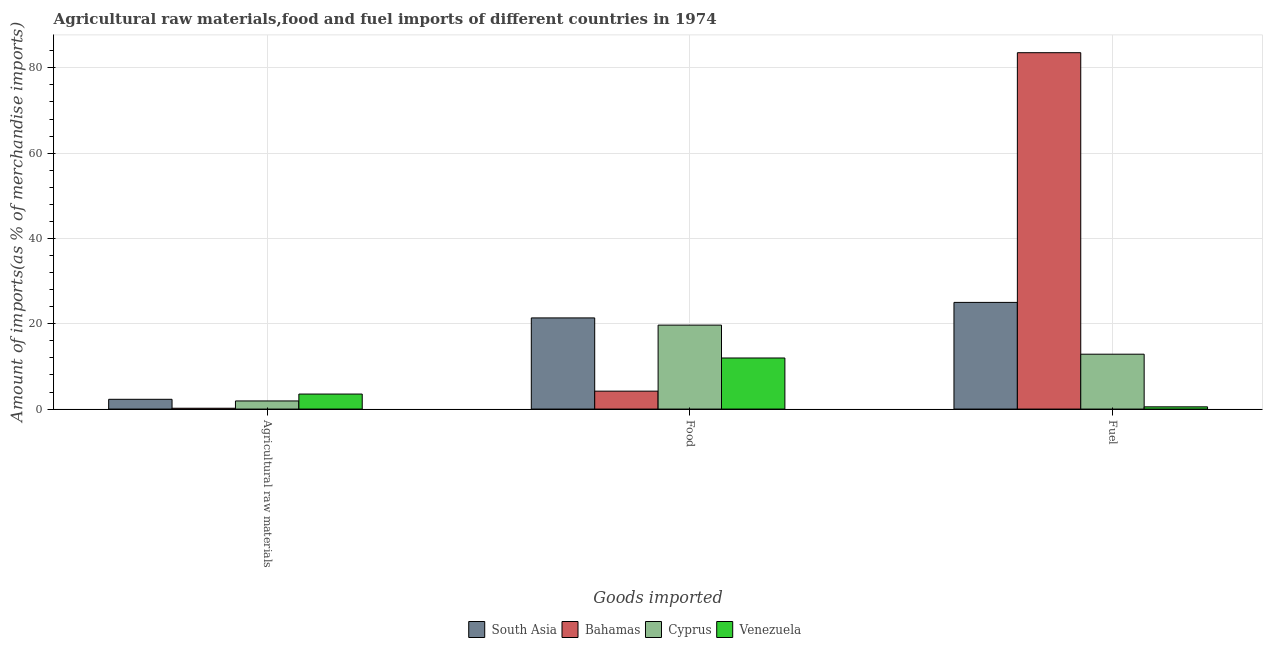How many groups of bars are there?
Your answer should be compact. 3. Are the number of bars per tick equal to the number of legend labels?
Give a very brief answer. Yes. Are the number of bars on each tick of the X-axis equal?
Make the answer very short. Yes. How many bars are there on the 3rd tick from the left?
Offer a terse response. 4. What is the label of the 1st group of bars from the left?
Provide a short and direct response. Agricultural raw materials. What is the percentage of food imports in Venezuela?
Offer a terse response. 11.98. Across all countries, what is the maximum percentage of fuel imports?
Your answer should be compact. 83.55. Across all countries, what is the minimum percentage of fuel imports?
Offer a terse response. 0.52. In which country was the percentage of raw materials imports maximum?
Provide a succinct answer. Venezuela. In which country was the percentage of fuel imports minimum?
Provide a short and direct response. Venezuela. What is the total percentage of food imports in the graph?
Make the answer very short. 57.24. What is the difference between the percentage of food imports in South Asia and that in Cyprus?
Provide a short and direct response. 1.69. What is the difference between the percentage of fuel imports in Cyprus and the percentage of food imports in South Asia?
Your response must be concise. -8.5. What is the average percentage of fuel imports per country?
Your answer should be very brief. 30.49. What is the difference between the percentage of fuel imports and percentage of food imports in Cyprus?
Your answer should be very brief. -6.82. In how many countries, is the percentage of fuel imports greater than 72 %?
Keep it short and to the point. 1. What is the ratio of the percentage of raw materials imports in Cyprus to that in Bahamas?
Provide a succinct answer. 9.67. Is the percentage of food imports in Cyprus less than that in Bahamas?
Keep it short and to the point. No. What is the difference between the highest and the second highest percentage of food imports?
Your answer should be compact. 1.69. What is the difference between the highest and the lowest percentage of raw materials imports?
Your answer should be very brief. 3.33. In how many countries, is the percentage of raw materials imports greater than the average percentage of raw materials imports taken over all countries?
Keep it short and to the point. 2. Is the sum of the percentage of raw materials imports in Bahamas and South Asia greater than the maximum percentage of food imports across all countries?
Keep it short and to the point. No. What does the 3rd bar from the left in Food represents?
Offer a very short reply. Cyprus. What does the 2nd bar from the right in Agricultural raw materials represents?
Your answer should be compact. Cyprus. Are all the bars in the graph horizontal?
Your response must be concise. No. How many countries are there in the graph?
Keep it short and to the point. 4. How are the legend labels stacked?
Ensure brevity in your answer.  Horizontal. What is the title of the graph?
Give a very brief answer. Agricultural raw materials,food and fuel imports of different countries in 1974. Does "Monaco" appear as one of the legend labels in the graph?
Keep it short and to the point. No. What is the label or title of the X-axis?
Your answer should be compact. Goods imported. What is the label or title of the Y-axis?
Give a very brief answer. Amount of imports(as % of merchandise imports). What is the Amount of imports(as % of merchandise imports) in South Asia in Agricultural raw materials?
Provide a short and direct response. 2.29. What is the Amount of imports(as % of merchandise imports) of Bahamas in Agricultural raw materials?
Your answer should be compact. 0.2. What is the Amount of imports(as % of merchandise imports) in Cyprus in Agricultural raw materials?
Offer a terse response. 1.91. What is the Amount of imports(as % of merchandise imports) in Venezuela in Agricultural raw materials?
Your answer should be compact. 3.52. What is the Amount of imports(as % of merchandise imports) in South Asia in Food?
Provide a short and direct response. 21.37. What is the Amount of imports(as % of merchandise imports) in Bahamas in Food?
Ensure brevity in your answer.  4.2. What is the Amount of imports(as % of merchandise imports) of Cyprus in Food?
Provide a succinct answer. 19.68. What is the Amount of imports(as % of merchandise imports) in Venezuela in Food?
Offer a terse response. 11.98. What is the Amount of imports(as % of merchandise imports) in South Asia in Fuel?
Give a very brief answer. 25.01. What is the Amount of imports(as % of merchandise imports) of Bahamas in Fuel?
Provide a short and direct response. 83.55. What is the Amount of imports(as % of merchandise imports) in Cyprus in Fuel?
Offer a very short reply. 12.87. What is the Amount of imports(as % of merchandise imports) of Venezuela in Fuel?
Provide a succinct answer. 0.52. Across all Goods imported, what is the maximum Amount of imports(as % of merchandise imports) of South Asia?
Offer a terse response. 25.01. Across all Goods imported, what is the maximum Amount of imports(as % of merchandise imports) of Bahamas?
Provide a succinct answer. 83.55. Across all Goods imported, what is the maximum Amount of imports(as % of merchandise imports) in Cyprus?
Keep it short and to the point. 19.68. Across all Goods imported, what is the maximum Amount of imports(as % of merchandise imports) of Venezuela?
Ensure brevity in your answer.  11.98. Across all Goods imported, what is the minimum Amount of imports(as % of merchandise imports) of South Asia?
Offer a terse response. 2.29. Across all Goods imported, what is the minimum Amount of imports(as % of merchandise imports) of Bahamas?
Keep it short and to the point. 0.2. Across all Goods imported, what is the minimum Amount of imports(as % of merchandise imports) of Cyprus?
Your answer should be very brief. 1.91. Across all Goods imported, what is the minimum Amount of imports(as % of merchandise imports) in Venezuela?
Your answer should be very brief. 0.52. What is the total Amount of imports(as % of merchandise imports) in South Asia in the graph?
Keep it short and to the point. 48.67. What is the total Amount of imports(as % of merchandise imports) in Bahamas in the graph?
Ensure brevity in your answer.  87.95. What is the total Amount of imports(as % of merchandise imports) of Cyprus in the graph?
Your response must be concise. 34.46. What is the total Amount of imports(as % of merchandise imports) of Venezuela in the graph?
Offer a very short reply. 16.02. What is the difference between the Amount of imports(as % of merchandise imports) in South Asia in Agricultural raw materials and that in Food?
Make the answer very short. -19.08. What is the difference between the Amount of imports(as % of merchandise imports) of Bahamas in Agricultural raw materials and that in Food?
Ensure brevity in your answer.  -4.01. What is the difference between the Amount of imports(as % of merchandise imports) in Cyprus in Agricultural raw materials and that in Food?
Your answer should be compact. -17.78. What is the difference between the Amount of imports(as % of merchandise imports) of Venezuela in Agricultural raw materials and that in Food?
Your answer should be compact. -8.45. What is the difference between the Amount of imports(as % of merchandise imports) in South Asia in Agricultural raw materials and that in Fuel?
Make the answer very short. -22.72. What is the difference between the Amount of imports(as % of merchandise imports) of Bahamas in Agricultural raw materials and that in Fuel?
Ensure brevity in your answer.  -83.36. What is the difference between the Amount of imports(as % of merchandise imports) of Cyprus in Agricultural raw materials and that in Fuel?
Make the answer very short. -10.96. What is the difference between the Amount of imports(as % of merchandise imports) of Venezuela in Agricultural raw materials and that in Fuel?
Your answer should be very brief. 3. What is the difference between the Amount of imports(as % of merchandise imports) of South Asia in Food and that in Fuel?
Offer a very short reply. -3.64. What is the difference between the Amount of imports(as % of merchandise imports) in Bahamas in Food and that in Fuel?
Provide a succinct answer. -79.35. What is the difference between the Amount of imports(as % of merchandise imports) in Cyprus in Food and that in Fuel?
Offer a terse response. 6.82. What is the difference between the Amount of imports(as % of merchandise imports) of Venezuela in Food and that in Fuel?
Your response must be concise. 11.45. What is the difference between the Amount of imports(as % of merchandise imports) in South Asia in Agricultural raw materials and the Amount of imports(as % of merchandise imports) in Bahamas in Food?
Your answer should be compact. -1.91. What is the difference between the Amount of imports(as % of merchandise imports) in South Asia in Agricultural raw materials and the Amount of imports(as % of merchandise imports) in Cyprus in Food?
Keep it short and to the point. -17.39. What is the difference between the Amount of imports(as % of merchandise imports) in South Asia in Agricultural raw materials and the Amount of imports(as % of merchandise imports) in Venezuela in Food?
Keep it short and to the point. -9.69. What is the difference between the Amount of imports(as % of merchandise imports) in Bahamas in Agricultural raw materials and the Amount of imports(as % of merchandise imports) in Cyprus in Food?
Provide a succinct answer. -19.49. What is the difference between the Amount of imports(as % of merchandise imports) in Bahamas in Agricultural raw materials and the Amount of imports(as % of merchandise imports) in Venezuela in Food?
Your answer should be very brief. -11.78. What is the difference between the Amount of imports(as % of merchandise imports) in Cyprus in Agricultural raw materials and the Amount of imports(as % of merchandise imports) in Venezuela in Food?
Your response must be concise. -10.07. What is the difference between the Amount of imports(as % of merchandise imports) in South Asia in Agricultural raw materials and the Amount of imports(as % of merchandise imports) in Bahamas in Fuel?
Provide a short and direct response. -81.26. What is the difference between the Amount of imports(as % of merchandise imports) of South Asia in Agricultural raw materials and the Amount of imports(as % of merchandise imports) of Cyprus in Fuel?
Your response must be concise. -10.58. What is the difference between the Amount of imports(as % of merchandise imports) in South Asia in Agricultural raw materials and the Amount of imports(as % of merchandise imports) in Venezuela in Fuel?
Provide a succinct answer. 1.77. What is the difference between the Amount of imports(as % of merchandise imports) in Bahamas in Agricultural raw materials and the Amount of imports(as % of merchandise imports) in Cyprus in Fuel?
Ensure brevity in your answer.  -12.67. What is the difference between the Amount of imports(as % of merchandise imports) in Bahamas in Agricultural raw materials and the Amount of imports(as % of merchandise imports) in Venezuela in Fuel?
Provide a succinct answer. -0.33. What is the difference between the Amount of imports(as % of merchandise imports) of Cyprus in Agricultural raw materials and the Amount of imports(as % of merchandise imports) of Venezuela in Fuel?
Provide a short and direct response. 1.38. What is the difference between the Amount of imports(as % of merchandise imports) in South Asia in Food and the Amount of imports(as % of merchandise imports) in Bahamas in Fuel?
Ensure brevity in your answer.  -62.18. What is the difference between the Amount of imports(as % of merchandise imports) of South Asia in Food and the Amount of imports(as % of merchandise imports) of Cyprus in Fuel?
Keep it short and to the point. 8.5. What is the difference between the Amount of imports(as % of merchandise imports) of South Asia in Food and the Amount of imports(as % of merchandise imports) of Venezuela in Fuel?
Provide a succinct answer. 20.85. What is the difference between the Amount of imports(as % of merchandise imports) in Bahamas in Food and the Amount of imports(as % of merchandise imports) in Cyprus in Fuel?
Your response must be concise. -8.66. What is the difference between the Amount of imports(as % of merchandise imports) of Bahamas in Food and the Amount of imports(as % of merchandise imports) of Venezuela in Fuel?
Your answer should be very brief. 3.68. What is the difference between the Amount of imports(as % of merchandise imports) of Cyprus in Food and the Amount of imports(as % of merchandise imports) of Venezuela in Fuel?
Ensure brevity in your answer.  19.16. What is the average Amount of imports(as % of merchandise imports) in South Asia per Goods imported?
Keep it short and to the point. 16.22. What is the average Amount of imports(as % of merchandise imports) of Bahamas per Goods imported?
Keep it short and to the point. 29.32. What is the average Amount of imports(as % of merchandise imports) in Cyprus per Goods imported?
Offer a terse response. 11.49. What is the average Amount of imports(as % of merchandise imports) of Venezuela per Goods imported?
Your answer should be very brief. 5.34. What is the difference between the Amount of imports(as % of merchandise imports) in South Asia and Amount of imports(as % of merchandise imports) in Bahamas in Agricultural raw materials?
Give a very brief answer. 2.09. What is the difference between the Amount of imports(as % of merchandise imports) of South Asia and Amount of imports(as % of merchandise imports) of Cyprus in Agricultural raw materials?
Offer a terse response. 0.39. What is the difference between the Amount of imports(as % of merchandise imports) of South Asia and Amount of imports(as % of merchandise imports) of Venezuela in Agricultural raw materials?
Ensure brevity in your answer.  -1.23. What is the difference between the Amount of imports(as % of merchandise imports) of Bahamas and Amount of imports(as % of merchandise imports) of Cyprus in Agricultural raw materials?
Give a very brief answer. -1.71. What is the difference between the Amount of imports(as % of merchandise imports) in Bahamas and Amount of imports(as % of merchandise imports) in Venezuela in Agricultural raw materials?
Keep it short and to the point. -3.33. What is the difference between the Amount of imports(as % of merchandise imports) of Cyprus and Amount of imports(as % of merchandise imports) of Venezuela in Agricultural raw materials?
Your response must be concise. -1.62. What is the difference between the Amount of imports(as % of merchandise imports) of South Asia and Amount of imports(as % of merchandise imports) of Bahamas in Food?
Offer a very short reply. 17.17. What is the difference between the Amount of imports(as % of merchandise imports) in South Asia and Amount of imports(as % of merchandise imports) in Cyprus in Food?
Provide a succinct answer. 1.69. What is the difference between the Amount of imports(as % of merchandise imports) in South Asia and Amount of imports(as % of merchandise imports) in Venezuela in Food?
Your answer should be compact. 9.39. What is the difference between the Amount of imports(as % of merchandise imports) in Bahamas and Amount of imports(as % of merchandise imports) in Cyprus in Food?
Provide a succinct answer. -15.48. What is the difference between the Amount of imports(as % of merchandise imports) of Bahamas and Amount of imports(as % of merchandise imports) of Venezuela in Food?
Make the answer very short. -7.77. What is the difference between the Amount of imports(as % of merchandise imports) in Cyprus and Amount of imports(as % of merchandise imports) in Venezuela in Food?
Provide a short and direct response. 7.71. What is the difference between the Amount of imports(as % of merchandise imports) of South Asia and Amount of imports(as % of merchandise imports) of Bahamas in Fuel?
Provide a succinct answer. -58.54. What is the difference between the Amount of imports(as % of merchandise imports) in South Asia and Amount of imports(as % of merchandise imports) in Cyprus in Fuel?
Provide a short and direct response. 12.14. What is the difference between the Amount of imports(as % of merchandise imports) in South Asia and Amount of imports(as % of merchandise imports) in Venezuela in Fuel?
Your response must be concise. 24.49. What is the difference between the Amount of imports(as % of merchandise imports) in Bahamas and Amount of imports(as % of merchandise imports) in Cyprus in Fuel?
Your answer should be very brief. 70.68. What is the difference between the Amount of imports(as % of merchandise imports) in Bahamas and Amount of imports(as % of merchandise imports) in Venezuela in Fuel?
Provide a succinct answer. 83.03. What is the difference between the Amount of imports(as % of merchandise imports) of Cyprus and Amount of imports(as % of merchandise imports) of Venezuela in Fuel?
Offer a very short reply. 12.34. What is the ratio of the Amount of imports(as % of merchandise imports) of South Asia in Agricultural raw materials to that in Food?
Make the answer very short. 0.11. What is the ratio of the Amount of imports(as % of merchandise imports) in Bahamas in Agricultural raw materials to that in Food?
Your response must be concise. 0.05. What is the ratio of the Amount of imports(as % of merchandise imports) of Cyprus in Agricultural raw materials to that in Food?
Keep it short and to the point. 0.1. What is the ratio of the Amount of imports(as % of merchandise imports) of Venezuela in Agricultural raw materials to that in Food?
Your response must be concise. 0.29. What is the ratio of the Amount of imports(as % of merchandise imports) in South Asia in Agricultural raw materials to that in Fuel?
Your answer should be very brief. 0.09. What is the ratio of the Amount of imports(as % of merchandise imports) in Bahamas in Agricultural raw materials to that in Fuel?
Ensure brevity in your answer.  0. What is the ratio of the Amount of imports(as % of merchandise imports) of Cyprus in Agricultural raw materials to that in Fuel?
Your answer should be compact. 0.15. What is the ratio of the Amount of imports(as % of merchandise imports) of Venezuela in Agricultural raw materials to that in Fuel?
Your answer should be very brief. 6.72. What is the ratio of the Amount of imports(as % of merchandise imports) in South Asia in Food to that in Fuel?
Ensure brevity in your answer.  0.85. What is the ratio of the Amount of imports(as % of merchandise imports) of Bahamas in Food to that in Fuel?
Ensure brevity in your answer.  0.05. What is the ratio of the Amount of imports(as % of merchandise imports) of Cyprus in Food to that in Fuel?
Provide a short and direct response. 1.53. What is the ratio of the Amount of imports(as % of merchandise imports) in Venezuela in Food to that in Fuel?
Keep it short and to the point. 22.86. What is the difference between the highest and the second highest Amount of imports(as % of merchandise imports) in South Asia?
Provide a succinct answer. 3.64. What is the difference between the highest and the second highest Amount of imports(as % of merchandise imports) of Bahamas?
Your answer should be very brief. 79.35. What is the difference between the highest and the second highest Amount of imports(as % of merchandise imports) of Cyprus?
Provide a short and direct response. 6.82. What is the difference between the highest and the second highest Amount of imports(as % of merchandise imports) of Venezuela?
Make the answer very short. 8.45. What is the difference between the highest and the lowest Amount of imports(as % of merchandise imports) in South Asia?
Give a very brief answer. 22.72. What is the difference between the highest and the lowest Amount of imports(as % of merchandise imports) of Bahamas?
Give a very brief answer. 83.36. What is the difference between the highest and the lowest Amount of imports(as % of merchandise imports) in Cyprus?
Provide a succinct answer. 17.78. What is the difference between the highest and the lowest Amount of imports(as % of merchandise imports) of Venezuela?
Your response must be concise. 11.45. 